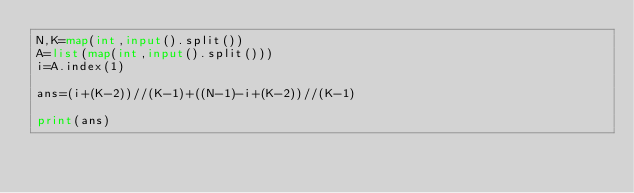Convert code to text. <code><loc_0><loc_0><loc_500><loc_500><_Python_>N,K=map(int,input().split())
A=list(map(int,input().split()))
i=A.index(1)

ans=(i+(K-2))//(K-1)+((N-1)-i+(K-2))//(K-1)

print(ans)</code> 